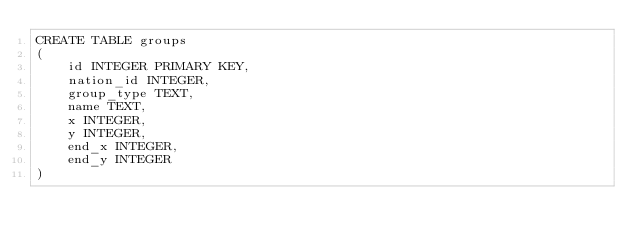Convert code to text. <code><loc_0><loc_0><loc_500><loc_500><_SQL_>CREATE TABLE groups
(
    id INTEGER PRIMARY KEY,
    nation_id INTEGER,
    group_type TEXT,
    name TEXT,
    x INTEGER,
    y INTEGER,
    end_x INTEGER,
    end_y INTEGER
)
</code> 